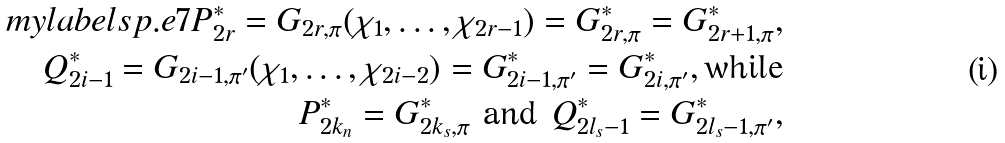<formula> <loc_0><loc_0><loc_500><loc_500>\ m y l a b e l { s p . e 7 } P _ { 2 r } ^ { * } = G _ { 2 r , \pi } ( \chi _ { 1 } , \dots , \chi _ { 2 r - 1 } ) = G _ { 2 r , \pi } ^ { * } = G _ { 2 r + 1 , \pi } ^ { * } , \\ Q _ { 2 i - 1 } ^ { * } = G _ { 2 i - 1 , \pi ^ { \prime } } ( \chi _ { 1 } , \dots , \chi _ { 2 i - 2 } ) = G _ { 2 i - 1 , \pi ^ { \prime } } ^ { * } = G _ { 2 i , \pi ^ { \prime } } ^ { * } , \text {while} \\ P _ { 2 k _ { n } } ^ { * } = G _ { 2 k _ { s } , \pi } ^ { * } \text { and } Q _ { 2 l _ { s } - 1 } ^ { * } = G _ { 2 l _ { s } - 1 , \pi ^ { \prime } } ^ { * } ,</formula> 